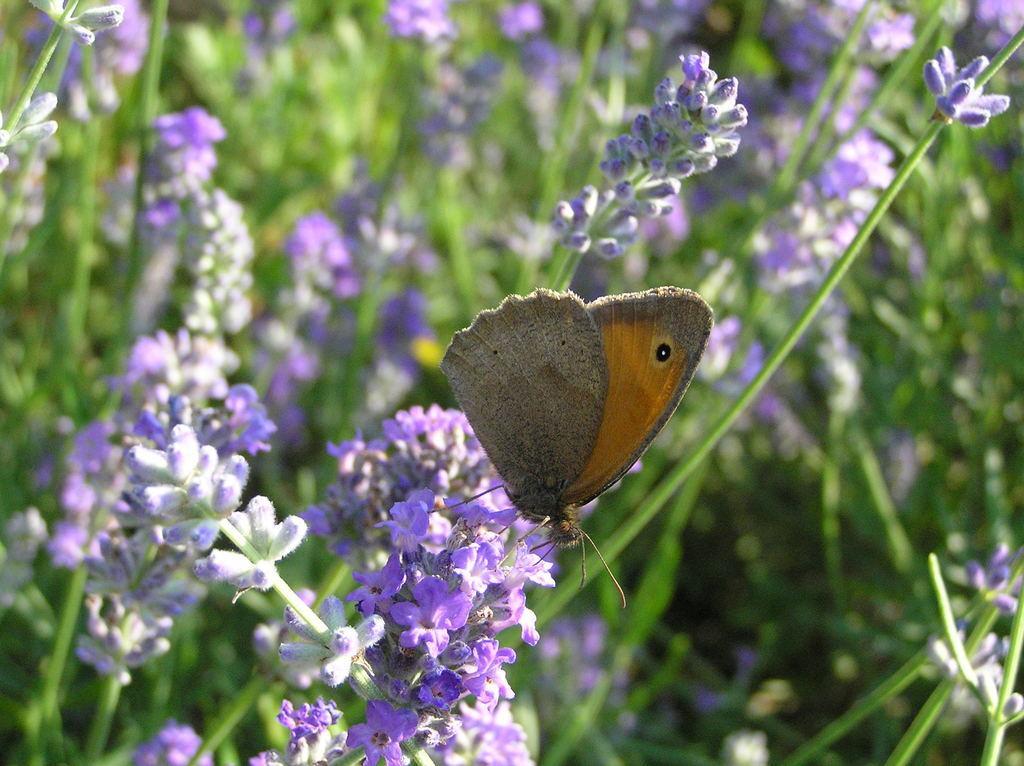What type of flowers are present in the image? There are blue color lavender flowers in the image. Is there any other living organism present in the image? Yes, a brown color butterfly is sitting on the flowers. How would you describe the background of the image? The background of the image is blurred. What page number is the crow found on in the image? There is no mention of a page or a crow in the image, so this question cannot be answered. 